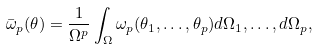<formula> <loc_0><loc_0><loc_500><loc_500>\bar { \omega } _ { p } ( \theta ) = \frac { 1 } { \Omega ^ { p } } \int _ { \Omega } \omega _ { p } ( \theta _ { 1 } , \dots , \theta _ { p } ) d \Omega _ { 1 } , \dots , d \Omega _ { p } ,</formula> 